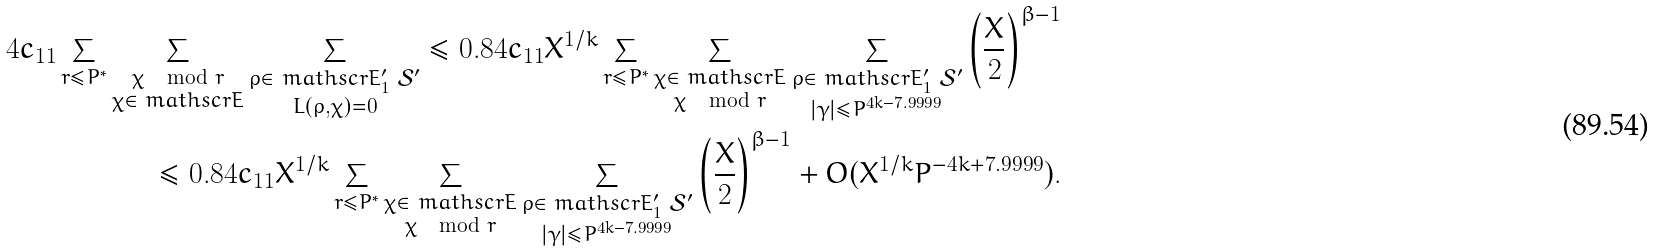<formula> <loc_0><loc_0><loc_500><loc_500>4 c _ { 1 1 } \sum _ { r \leq P { ^ { * } } } \sum _ { \substack { \chi \mod r \\ \chi \in \ m a t h s c r { E } } } \sum _ { \substack { \rho \in \ m a t h s c r { E } ^ { \prime } _ { 1 } \ \mathcal { S } ^ { \prime } \\ L ( \rho , \chi ) = 0 } } \leq 0 . 8 4 c _ { 1 1 } X ^ { 1 / k } \sum _ { r \leq P { ^ { * } } } \sum _ { \substack { \chi \in \ m a t h s c r { E } \\ \chi \mod r } } \sum _ { \substack { \rho \in \ m a t h s c r { E } ^ { \prime } _ { 1 } \ \mathcal { S } ^ { \prime } \\ | \gamma | \leq P ^ { 4 k - 7 . 9 9 9 9 } } } \left ( \frac { X } { 2 } \right ) ^ { \beta - 1 } \\ \leq 0 . 8 4 c _ { 1 1 } X ^ { 1 / k } \sum _ { r \leq P { ^ { * } } } \sum _ { \substack { \chi \in \ m a t h s c r { E } \\ \chi \mod r } } \sum _ { \substack { \rho \in \ m a t h s c r { E } ^ { \prime } _ { 1 } \ \mathcal { S } ^ { \prime } \\ | \gamma | \leq P ^ { 4 k - 7 . 9 9 9 9 } } } \left ( \frac { X } { 2 } \right ) ^ { \beta - 1 } + O ( X ^ { 1 / k } P ^ { - 4 k + 7 . 9 9 9 9 } ) .</formula> 